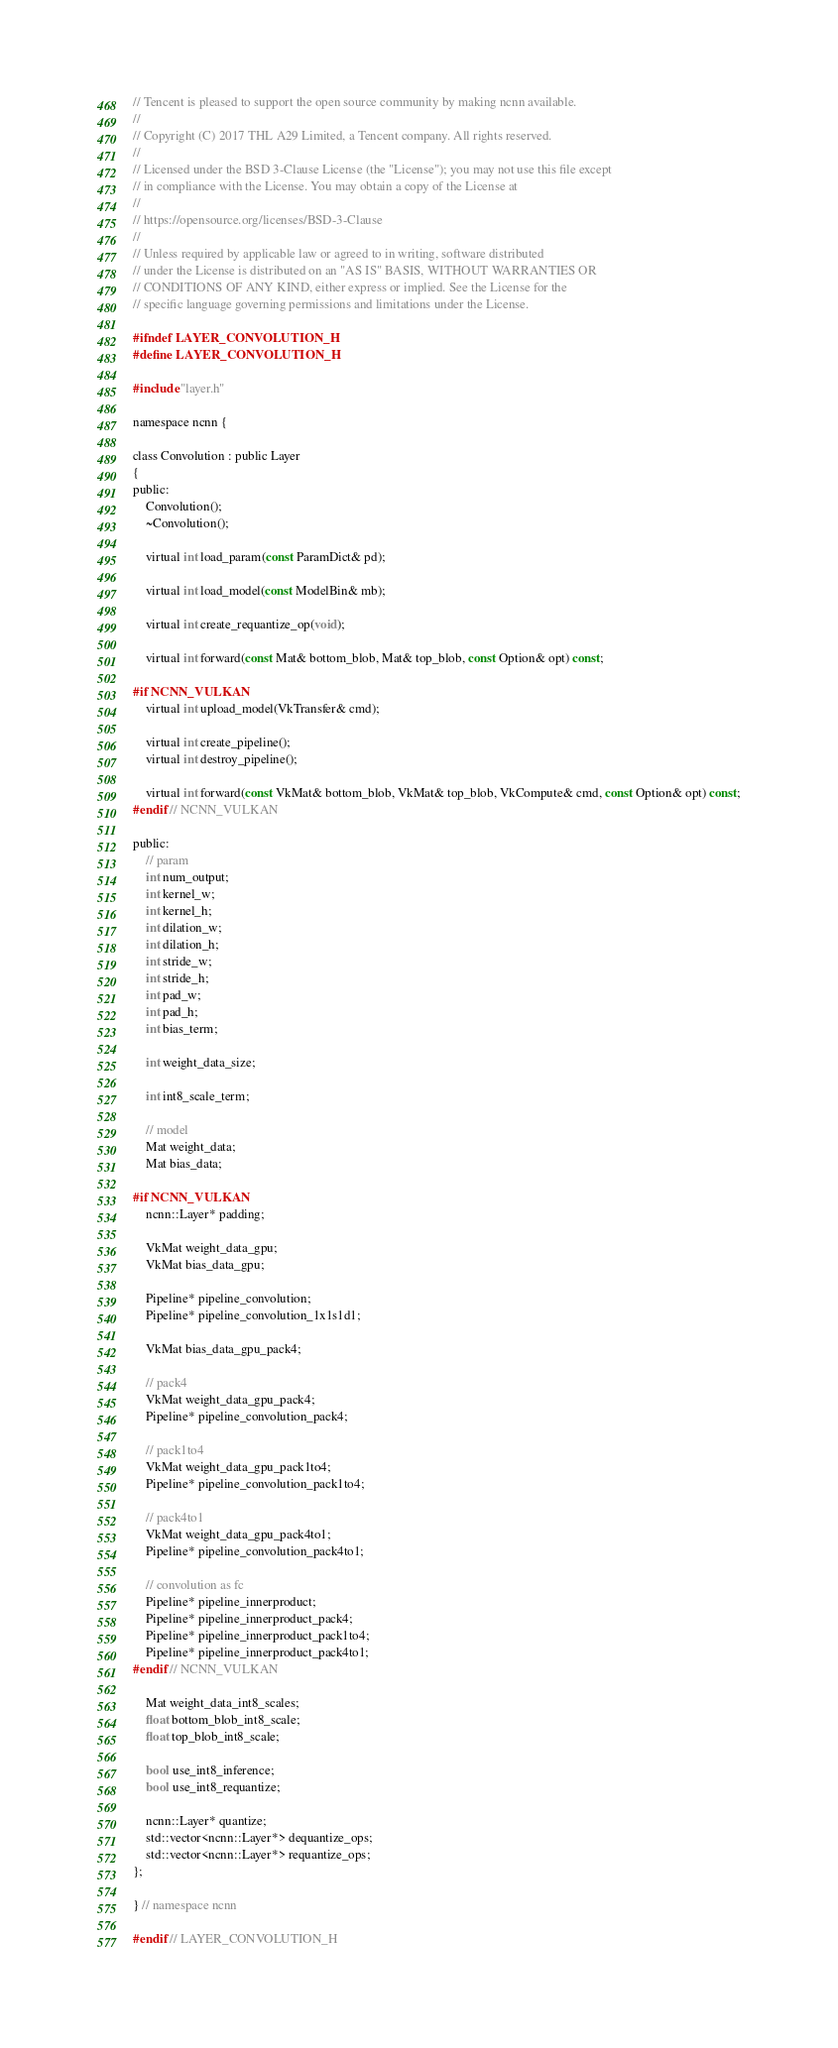<code> <loc_0><loc_0><loc_500><loc_500><_C_>// Tencent is pleased to support the open source community by making ncnn available.
//
// Copyright (C) 2017 THL A29 Limited, a Tencent company. All rights reserved.
//
// Licensed under the BSD 3-Clause License (the "License"); you may not use this file except
// in compliance with the License. You may obtain a copy of the License at
//
// https://opensource.org/licenses/BSD-3-Clause
//
// Unless required by applicable law or agreed to in writing, software distributed
// under the License is distributed on an "AS IS" BASIS, WITHOUT WARRANTIES OR
// CONDITIONS OF ANY KIND, either express or implied. See the License for the
// specific language governing permissions and limitations under the License.

#ifndef LAYER_CONVOLUTION_H
#define LAYER_CONVOLUTION_H

#include "layer.h"

namespace ncnn {

class Convolution : public Layer
{
public:
    Convolution();
    ~Convolution();

    virtual int load_param(const ParamDict& pd);

    virtual int load_model(const ModelBin& mb);

    virtual int create_requantize_op(void);

    virtual int forward(const Mat& bottom_blob, Mat& top_blob, const Option& opt) const;

#if NCNN_VULKAN
    virtual int upload_model(VkTransfer& cmd);

    virtual int create_pipeline();
    virtual int destroy_pipeline();

    virtual int forward(const VkMat& bottom_blob, VkMat& top_blob, VkCompute& cmd, const Option& opt) const;
#endif // NCNN_VULKAN

public:
    // param
    int num_output;
    int kernel_w;
    int kernel_h;
    int dilation_w;
    int dilation_h;
    int stride_w;
    int stride_h;
    int pad_w;
    int pad_h;
    int bias_term;

    int weight_data_size;

    int int8_scale_term;

    // model
    Mat weight_data;
    Mat bias_data;

#if NCNN_VULKAN
    ncnn::Layer* padding;

    VkMat weight_data_gpu;
    VkMat bias_data_gpu;

    Pipeline* pipeline_convolution;
    Pipeline* pipeline_convolution_1x1s1d1;

    VkMat bias_data_gpu_pack4;

    // pack4
    VkMat weight_data_gpu_pack4;
    Pipeline* pipeline_convolution_pack4;

    // pack1to4
    VkMat weight_data_gpu_pack1to4;
    Pipeline* pipeline_convolution_pack1to4;

    // pack4to1
    VkMat weight_data_gpu_pack4to1;
    Pipeline* pipeline_convolution_pack4to1;

    // convolution as fc
    Pipeline* pipeline_innerproduct;
    Pipeline* pipeline_innerproduct_pack4;
    Pipeline* pipeline_innerproduct_pack1to4;
    Pipeline* pipeline_innerproduct_pack4to1;
#endif // NCNN_VULKAN

    Mat weight_data_int8_scales;
    float bottom_blob_int8_scale;
    float top_blob_int8_scale;

    bool use_int8_inference;
    bool use_int8_requantize;

    ncnn::Layer* quantize;
    std::vector<ncnn::Layer*> dequantize_ops;
    std::vector<ncnn::Layer*> requantize_ops;
};

} // namespace ncnn

#endif // LAYER_CONVOLUTION_H
</code> 